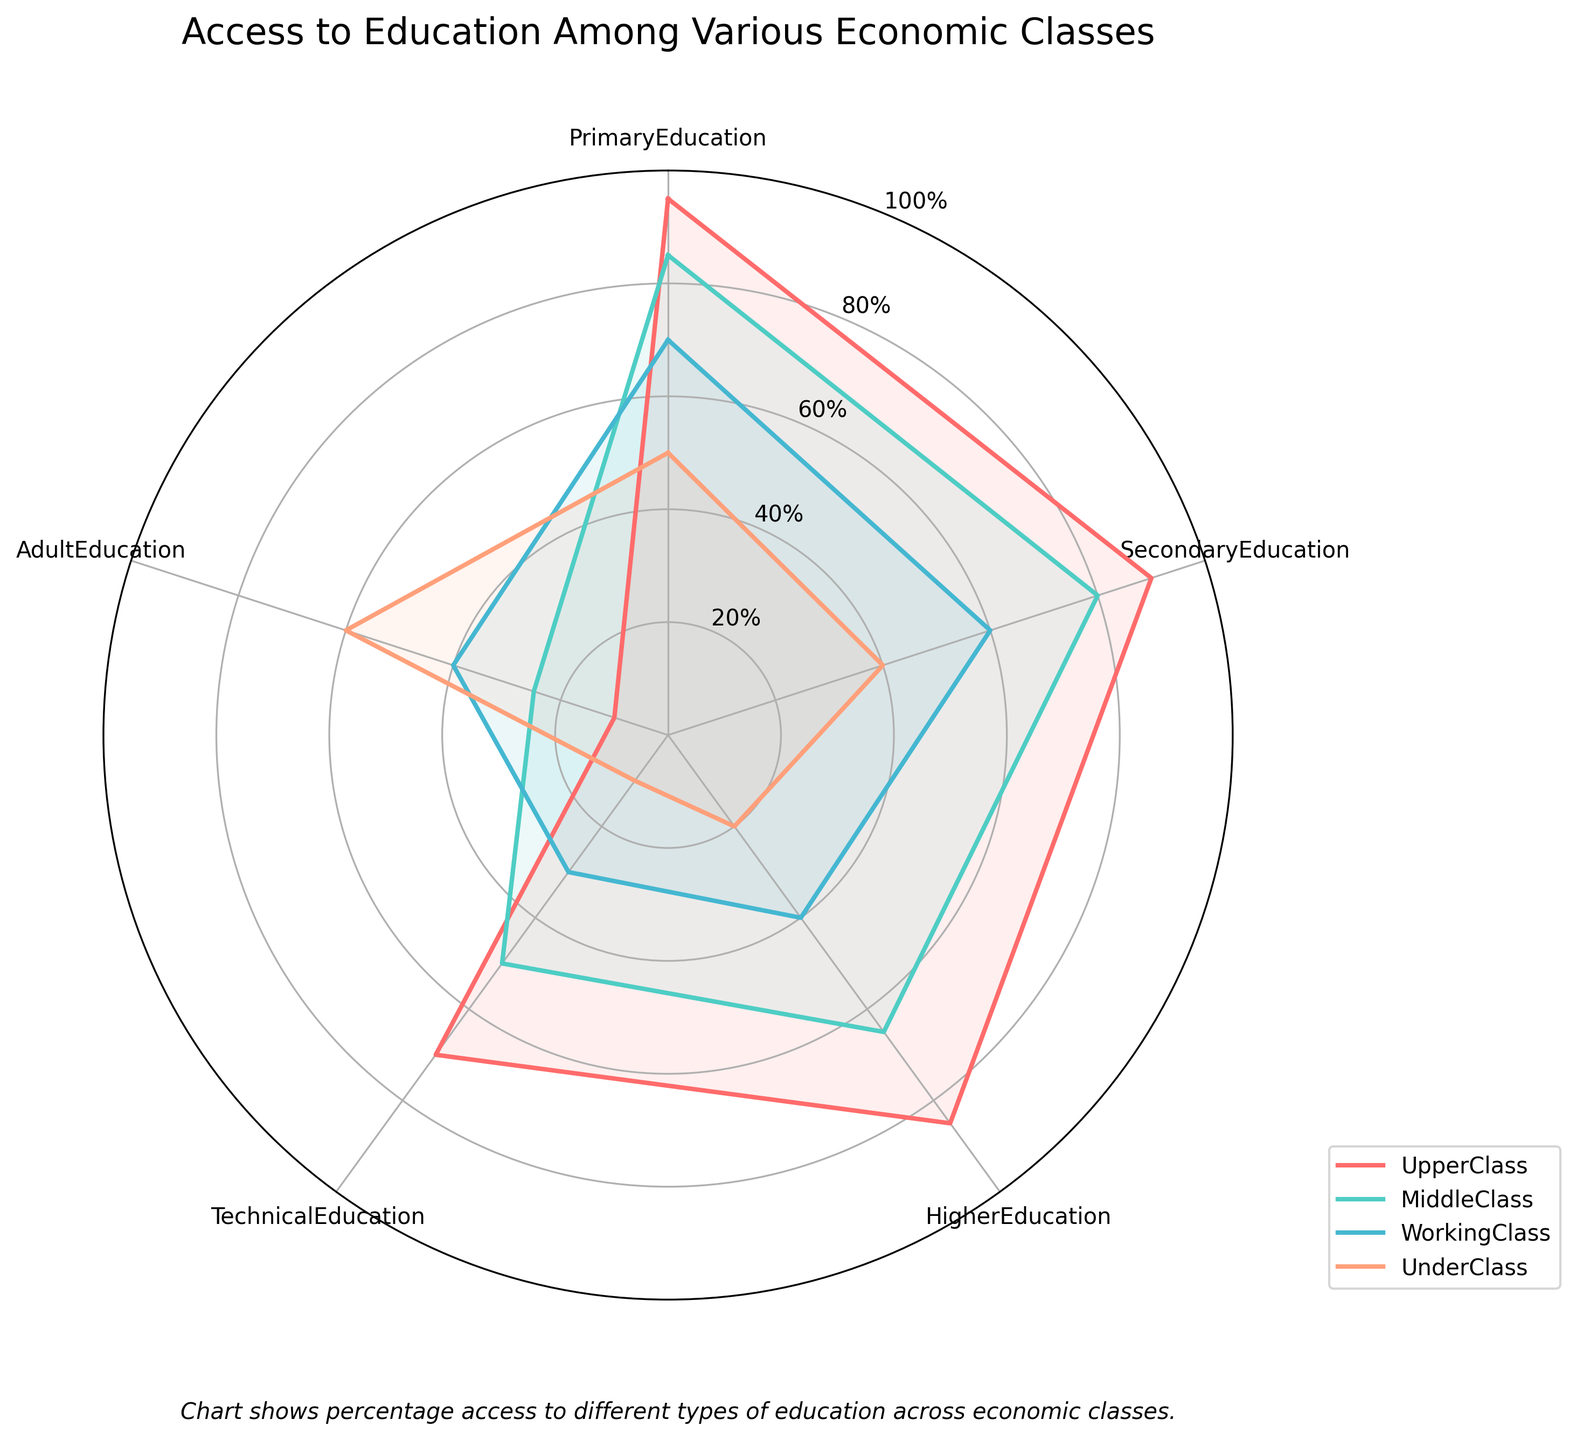What is the title of the radar chart? The title of the radar chart is located at the top of the figure and reads "Access to Education Among Various Economic Classes."
Answer: Access to Education Among Various Economic Classes How many categories of education are displayed in the radar chart? The categories of education are indicated around the outer edge of the radar chart, including Primary Education, Secondary Education, Higher Education, Technical Education, and Adult Education. Counting these gives a total of 5 categories.
Answer: 5 Which economic class has the highest access to higher education? By examining the plot lines for higher education, identified around the radar chart and with the label "HigherEducation," it can be seen that the line representing the UpperClass reaches the highest value at 85%.
Answer: UpperClass What's the difference in access to secondary education between the upper class and the underclass? The UpperClass has 90% access to secondary education, while the UnderClass has 40%. The difference can be calculated as 90 - 40 = 50%.
Answer: 50% What is the comparison in access to technical education between the MiddleClass and the WorkingClass? For technical education, the MiddleClass has 50% and the WorkingClass has 30%. Comparing these shows that the MiddleClass has greater access by a difference of 20%.
Answer: MiddleClass has greater access by 20% Which class has the least access to primary education? By checking the values at the corresponding points for primary education, the class with the lowest value is the UnderClass with 50%.
Answer: UnderClass How does the access to adult education compare between the UpperClass and the UnderClass? The UpperClass has 10% access to adult education, while the UnderClass has 60%. This shows the UnderClass has significantly higher access by 50%.
Answer: UnderClass has higher access by 50% What is the average access to education for the MiddleClass across all categories? The access percentages for the MiddleClass are: PrimaryEducation 85%, SecondaryEducation 80%, HigherEducation 65%, TechnicalEducation 50%, and AdultEducation 25%. The average is calculated as (85+80+65+50+25)/5 = 305/5 = 61%.
Answer: 61% Which class shows the largest variance in access across different education categories? The variance can be visually estimated by looking at the spread of the values. The UpperClass has a high of 95% and a low of 10% indicating a high variance. The UnderClass has access ranging from 10% to 60%, with higher values being close together. Thus, the UpperClass has the largest variance.
Answer: UpperClass 